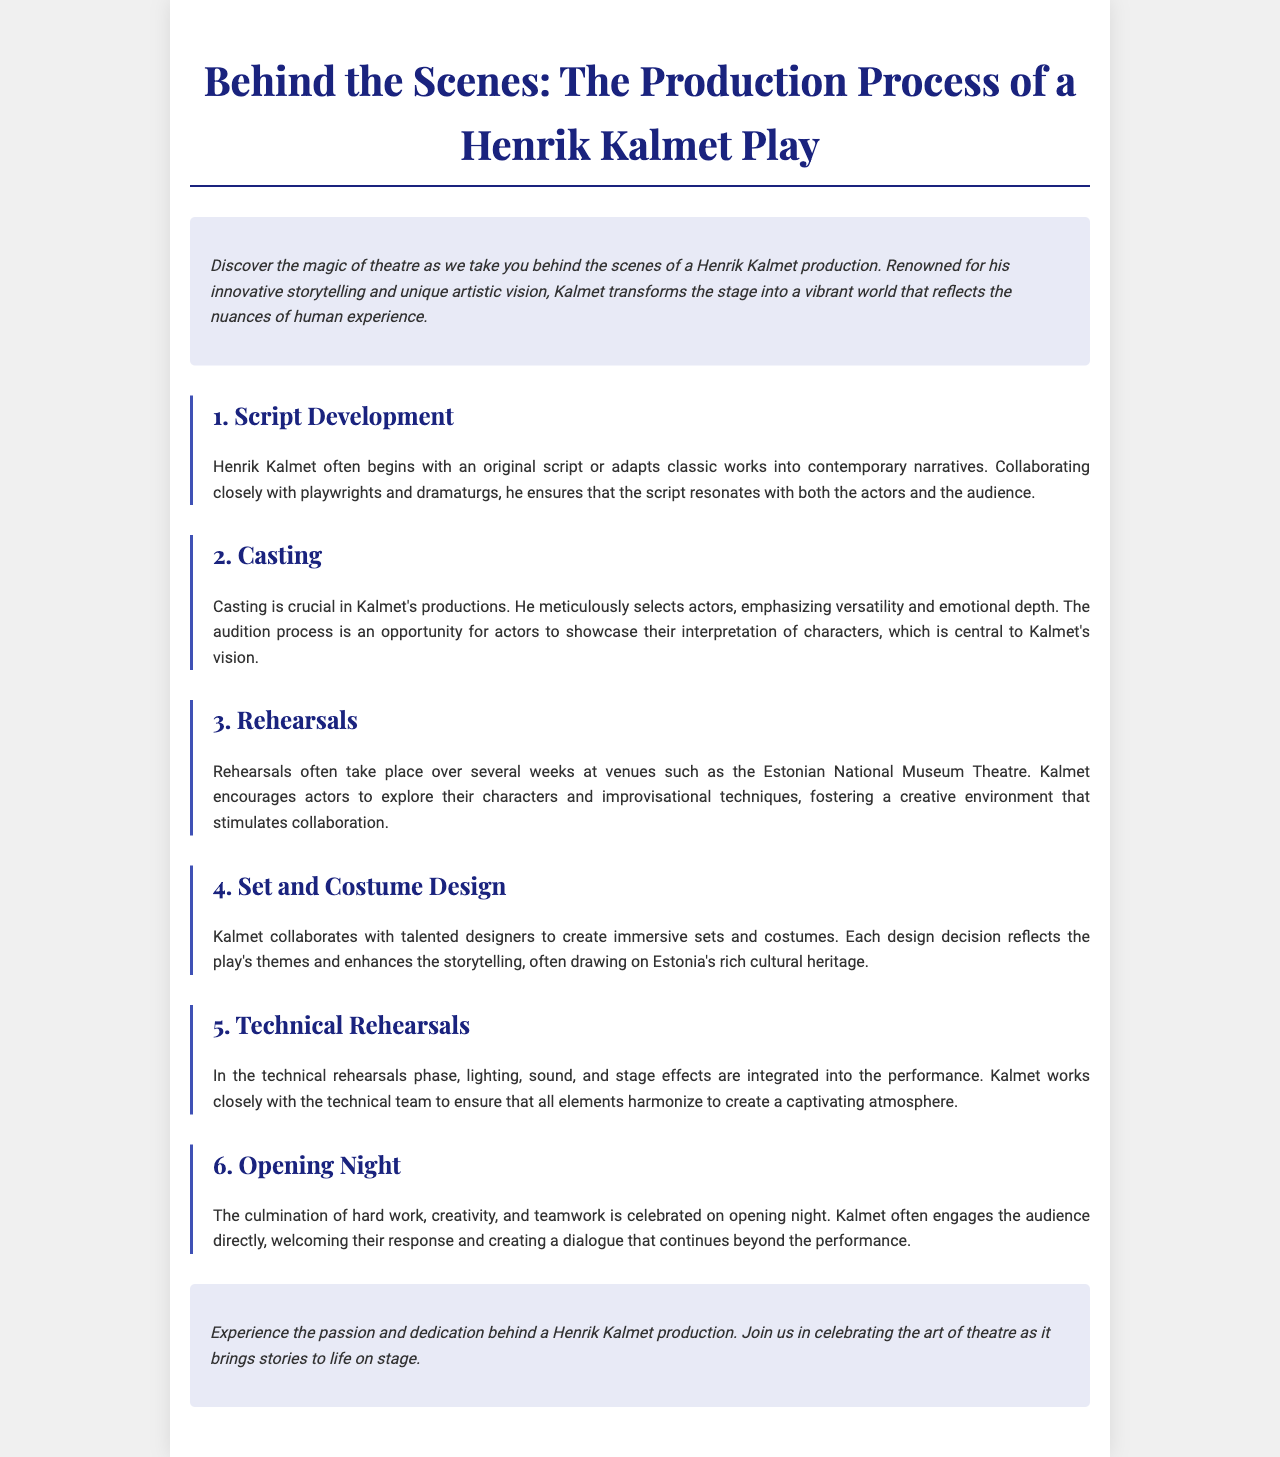What is the title of the brochure? The title is explicitly mentioned at the top of the document, showcasing the theme of the production process.
Answer: Behind the Scenes: The Production Process of a Henrik Kalmet Play Who collaborates with Henrik Kalmet during the script development? The document states that Kalmet collaborates closely with playwrights and dramaturgs in the script development section.
Answer: Playwrights and dramaturgs What is emphasized in the casting process? The casting section highlights that Kalmet emphasizes versatility and emotional depth in selecting actors.
Answer: Versatility and emotional depth Where do rehearsals typically take place? The rehearsals section specifies that they often take place at the Estonian National Museum Theatre.
Answer: Estonian National Museum Theatre What elements are integrated during the technical rehearsals? The technical rehearsals section lists lighting, sound, and stage effects as elements that are integrated into the performance.
Answer: Lighting, sound, and stage effects What is the atmosphere created on opening night? The opening night section indicates that Kalmet creates a captivating atmosphere that involves direct audience engagement.
Answer: Captivating atmosphere Which cultural heritage influences set and costume design? The set and costume design section mentions that the designs often draw on Estonia's rich cultural heritage.
Answer: Estonia's rich cultural heritage How long do rehearsals usually last? Although not explicitly mentioned, reasoning suggests rehearsals take place "over several weeks," as stated in the document.
Answer: Several weeks 